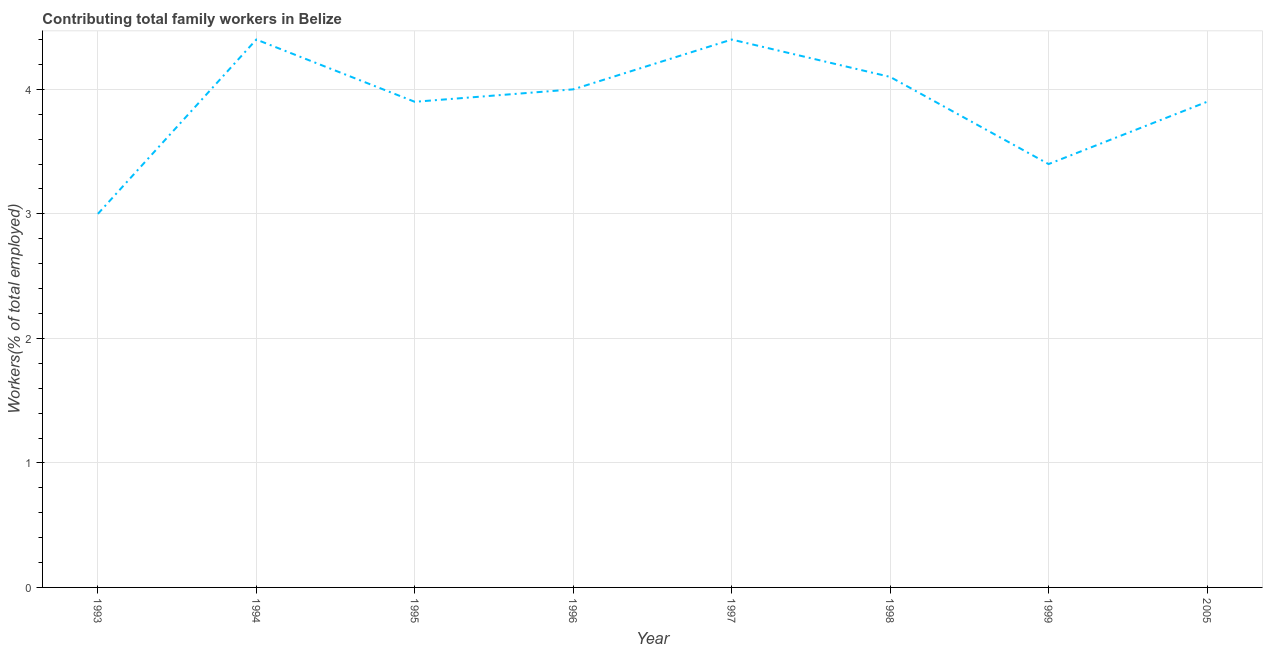Across all years, what is the maximum contributing family workers?
Keep it short and to the point. 4.4. In which year was the contributing family workers maximum?
Make the answer very short. 1994. What is the sum of the contributing family workers?
Your answer should be very brief. 31.1. What is the difference between the contributing family workers in 1996 and 1999?
Make the answer very short. 0.6. What is the average contributing family workers per year?
Provide a succinct answer. 3.89. What is the median contributing family workers?
Your answer should be compact. 3.95. Do a majority of the years between 1995 and 1994 (inclusive) have contributing family workers greater than 3.8 %?
Keep it short and to the point. No. What is the ratio of the contributing family workers in 1993 to that in 1994?
Offer a terse response. 0.68. Is the difference between the contributing family workers in 1994 and 1995 greater than the difference between any two years?
Make the answer very short. No. What is the difference between the highest and the second highest contributing family workers?
Keep it short and to the point. 0. What is the difference between the highest and the lowest contributing family workers?
Offer a terse response. 1.4. Does the contributing family workers monotonically increase over the years?
Your answer should be compact. No. How many lines are there?
Your response must be concise. 1. How many years are there in the graph?
Your answer should be compact. 8. Does the graph contain grids?
Your response must be concise. Yes. What is the title of the graph?
Offer a terse response. Contributing total family workers in Belize. What is the label or title of the Y-axis?
Provide a short and direct response. Workers(% of total employed). What is the Workers(% of total employed) in 1993?
Give a very brief answer. 3. What is the Workers(% of total employed) in 1994?
Your answer should be very brief. 4.4. What is the Workers(% of total employed) in 1995?
Provide a short and direct response. 3.9. What is the Workers(% of total employed) of 1996?
Provide a succinct answer. 4. What is the Workers(% of total employed) of 1997?
Provide a short and direct response. 4.4. What is the Workers(% of total employed) of 1998?
Give a very brief answer. 4.1. What is the Workers(% of total employed) of 1999?
Give a very brief answer. 3.4. What is the Workers(% of total employed) of 2005?
Provide a short and direct response. 3.9. What is the difference between the Workers(% of total employed) in 1993 and 1994?
Offer a very short reply. -1.4. What is the difference between the Workers(% of total employed) in 1993 and 1995?
Keep it short and to the point. -0.9. What is the difference between the Workers(% of total employed) in 1993 and 1996?
Ensure brevity in your answer.  -1. What is the difference between the Workers(% of total employed) in 1993 and 1997?
Your answer should be compact. -1.4. What is the difference between the Workers(% of total employed) in 1993 and 1999?
Ensure brevity in your answer.  -0.4. What is the difference between the Workers(% of total employed) in 1994 and 1996?
Offer a terse response. 0.4. What is the difference between the Workers(% of total employed) in 1994 and 1997?
Offer a terse response. 0. What is the difference between the Workers(% of total employed) in 1995 and 1999?
Ensure brevity in your answer.  0.5. What is the difference between the Workers(% of total employed) in 1995 and 2005?
Keep it short and to the point. 0. What is the difference between the Workers(% of total employed) in 1996 and 1999?
Your answer should be compact. 0.6. What is the difference between the Workers(% of total employed) in 1996 and 2005?
Make the answer very short. 0.1. What is the difference between the Workers(% of total employed) in 1997 and 1999?
Keep it short and to the point. 1. What is the difference between the Workers(% of total employed) in 1997 and 2005?
Your answer should be compact. 0.5. What is the difference between the Workers(% of total employed) in 1999 and 2005?
Give a very brief answer. -0.5. What is the ratio of the Workers(% of total employed) in 1993 to that in 1994?
Give a very brief answer. 0.68. What is the ratio of the Workers(% of total employed) in 1993 to that in 1995?
Ensure brevity in your answer.  0.77. What is the ratio of the Workers(% of total employed) in 1993 to that in 1997?
Ensure brevity in your answer.  0.68. What is the ratio of the Workers(% of total employed) in 1993 to that in 1998?
Your answer should be very brief. 0.73. What is the ratio of the Workers(% of total employed) in 1993 to that in 1999?
Your answer should be compact. 0.88. What is the ratio of the Workers(% of total employed) in 1993 to that in 2005?
Your answer should be compact. 0.77. What is the ratio of the Workers(% of total employed) in 1994 to that in 1995?
Ensure brevity in your answer.  1.13. What is the ratio of the Workers(% of total employed) in 1994 to that in 1996?
Offer a terse response. 1.1. What is the ratio of the Workers(% of total employed) in 1994 to that in 1997?
Provide a short and direct response. 1. What is the ratio of the Workers(% of total employed) in 1994 to that in 1998?
Give a very brief answer. 1.07. What is the ratio of the Workers(% of total employed) in 1994 to that in 1999?
Offer a terse response. 1.29. What is the ratio of the Workers(% of total employed) in 1994 to that in 2005?
Ensure brevity in your answer.  1.13. What is the ratio of the Workers(% of total employed) in 1995 to that in 1996?
Provide a succinct answer. 0.97. What is the ratio of the Workers(% of total employed) in 1995 to that in 1997?
Offer a terse response. 0.89. What is the ratio of the Workers(% of total employed) in 1995 to that in 1998?
Offer a very short reply. 0.95. What is the ratio of the Workers(% of total employed) in 1995 to that in 1999?
Ensure brevity in your answer.  1.15. What is the ratio of the Workers(% of total employed) in 1995 to that in 2005?
Keep it short and to the point. 1. What is the ratio of the Workers(% of total employed) in 1996 to that in 1997?
Offer a terse response. 0.91. What is the ratio of the Workers(% of total employed) in 1996 to that in 1998?
Keep it short and to the point. 0.98. What is the ratio of the Workers(% of total employed) in 1996 to that in 1999?
Make the answer very short. 1.18. What is the ratio of the Workers(% of total employed) in 1997 to that in 1998?
Provide a short and direct response. 1.07. What is the ratio of the Workers(% of total employed) in 1997 to that in 1999?
Your answer should be very brief. 1.29. What is the ratio of the Workers(% of total employed) in 1997 to that in 2005?
Ensure brevity in your answer.  1.13. What is the ratio of the Workers(% of total employed) in 1998 to that in 1999?
Keep it short and to the point. 1.21. What is the ratio of the Workers(% of total employed) in 1998 to that in 2005?
Make the answer very short. 1.05. What is the ratio of the Workers(% of total employed) in 1999 to that in 2005?
Offer a terse response. 0.87. 